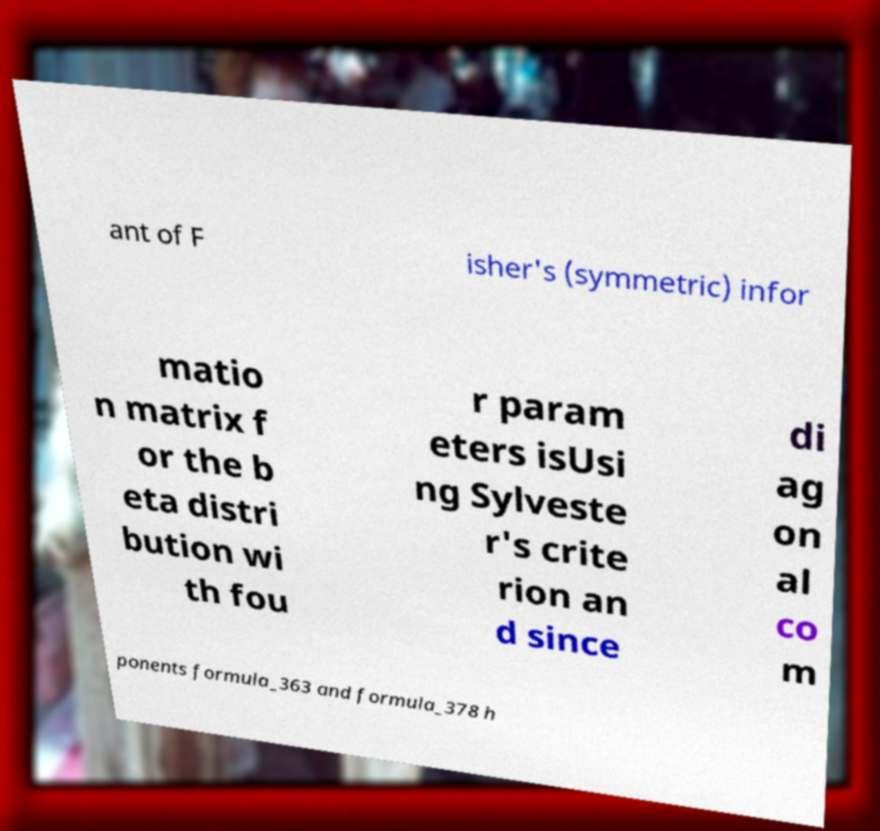There's text embedded in this image that I need extracted. Can you transcribe it verbatim? ant of F isher's (symmetric) infor matio n matrix f or the b eta distri bution wi th fou r param eters isUsi ng Sylveste r's crite rion an d since di ag on al co m ponents formula_363 and formula_378 h 